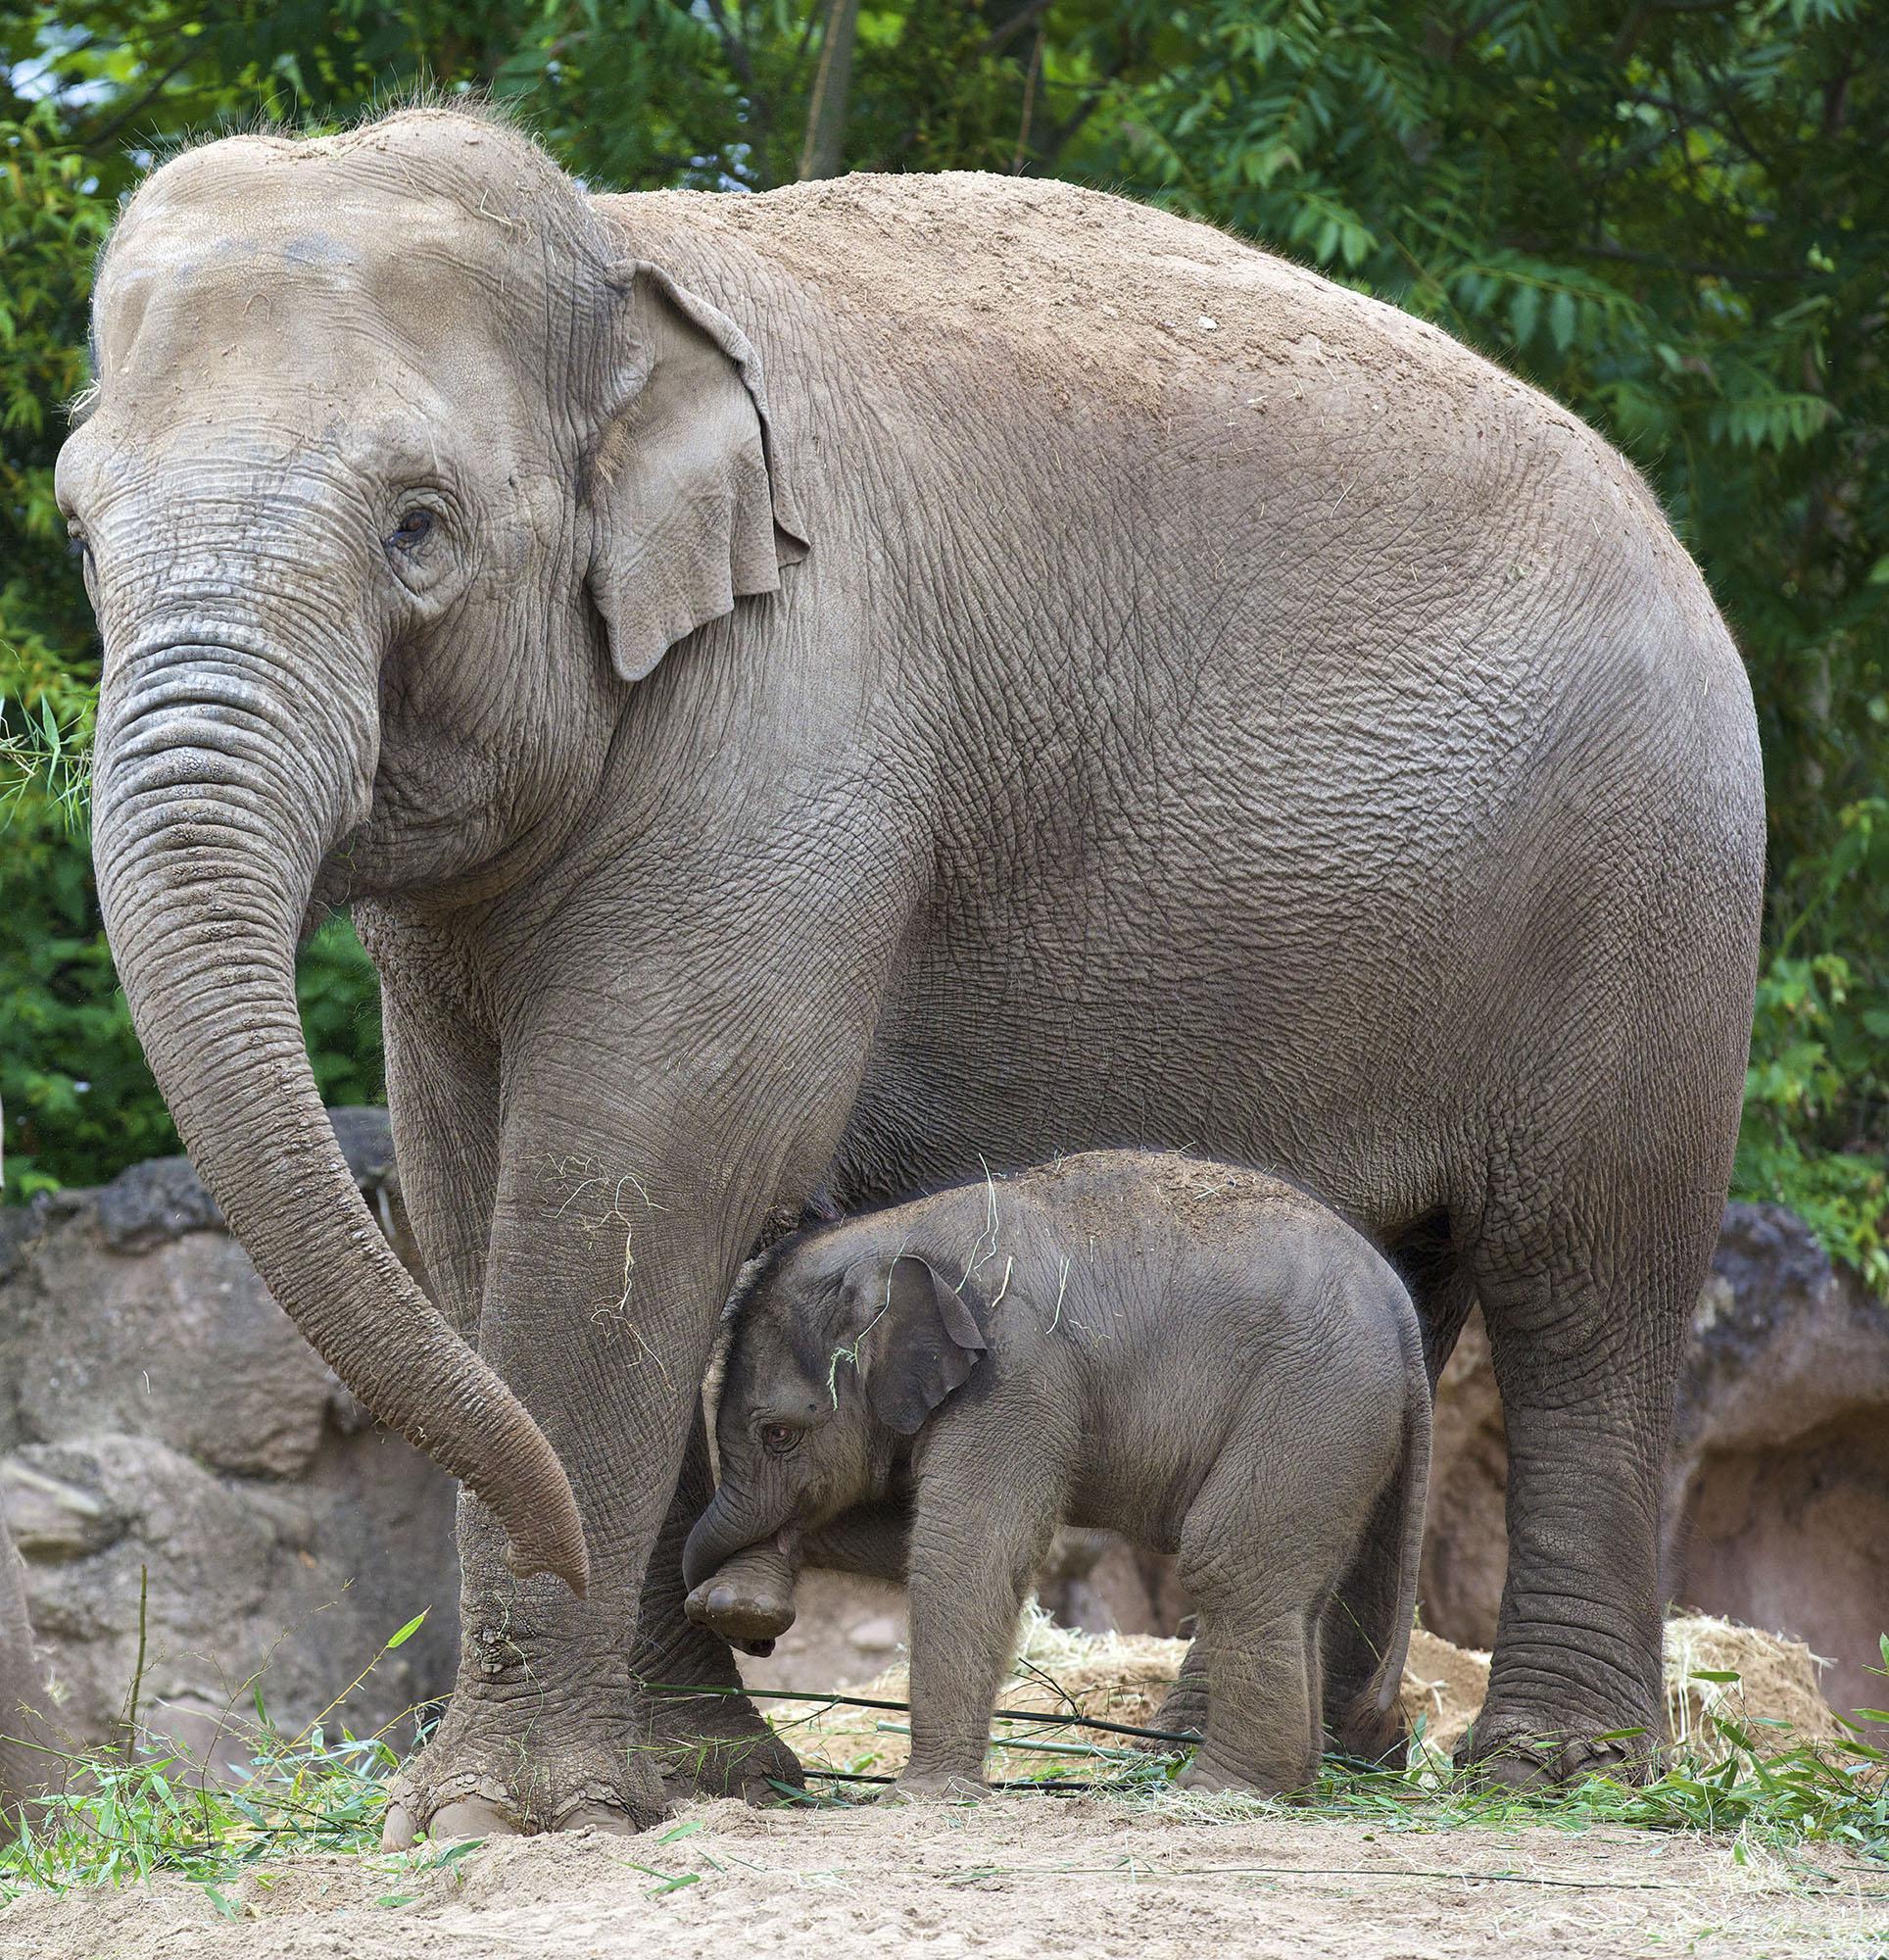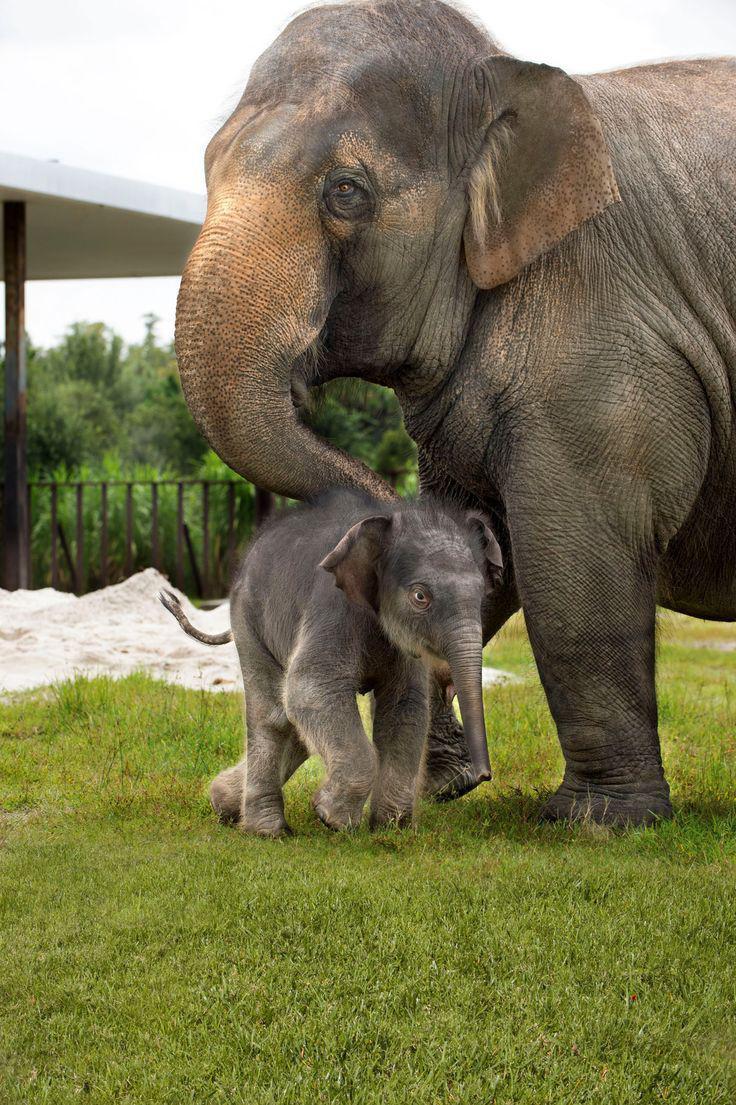The first image is the image on the left, the second image is the image on the right. For the images shown, is this caption "An image shows just one adult elephant interacting with a baby elephant on bright green grass." true? Answer yes or no. Yes. 